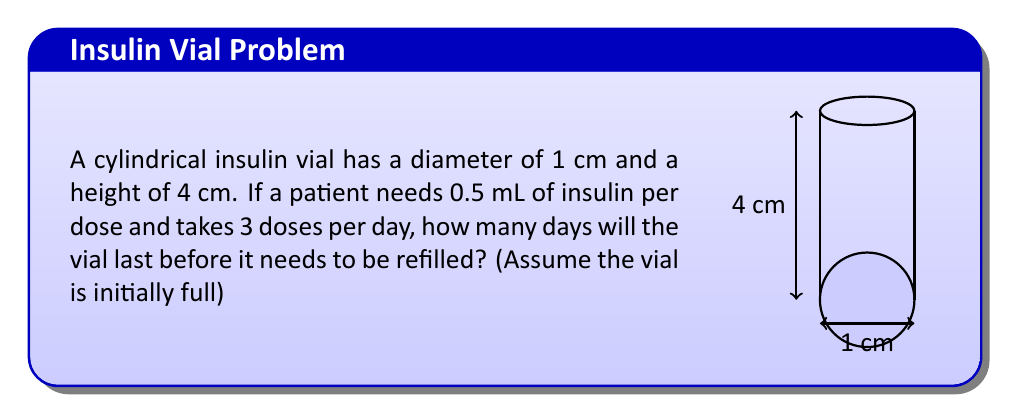What is the answer to this math problem? Let's approach this step-by-step:

1) First, we need to calculate the volume of the cylindrical vial:
   $$V = \pi r^2 h$$
   where $r$ is the radius and $h$ is the height.

2) The diameter is 1 cm, so the radius is 0.5 cm:
   $$V = \pi (0.5\text{ cm})^2 (4\text{ cm}) = \pi \text{ cm}^3$$

3) We need to convert this to milliliters:
   $$1 \text{ cm}^3 = 1 \text{ mL}$$
   So, the volume is $\pi \text{ mL} \approx 3.14 \text{ mL}$

4) The patient needs 0.5 mL per dose and takes 3 doses per day:
   Daily insulin requirement = $0.5 \text{ mL} \times 3 = 1.5 \text{ mL}$

5) To find how many days the vial will last, divide the total volume by the daily requirement:
   $$\text{Number of days} = \frac{3.14 \text{ mL}}{1.5 \text{ mL/day}} \approx 2.09 \text{ days}$$

6) Since we can't have a partial day, we round down to 2 days.
Answer: 2 days 